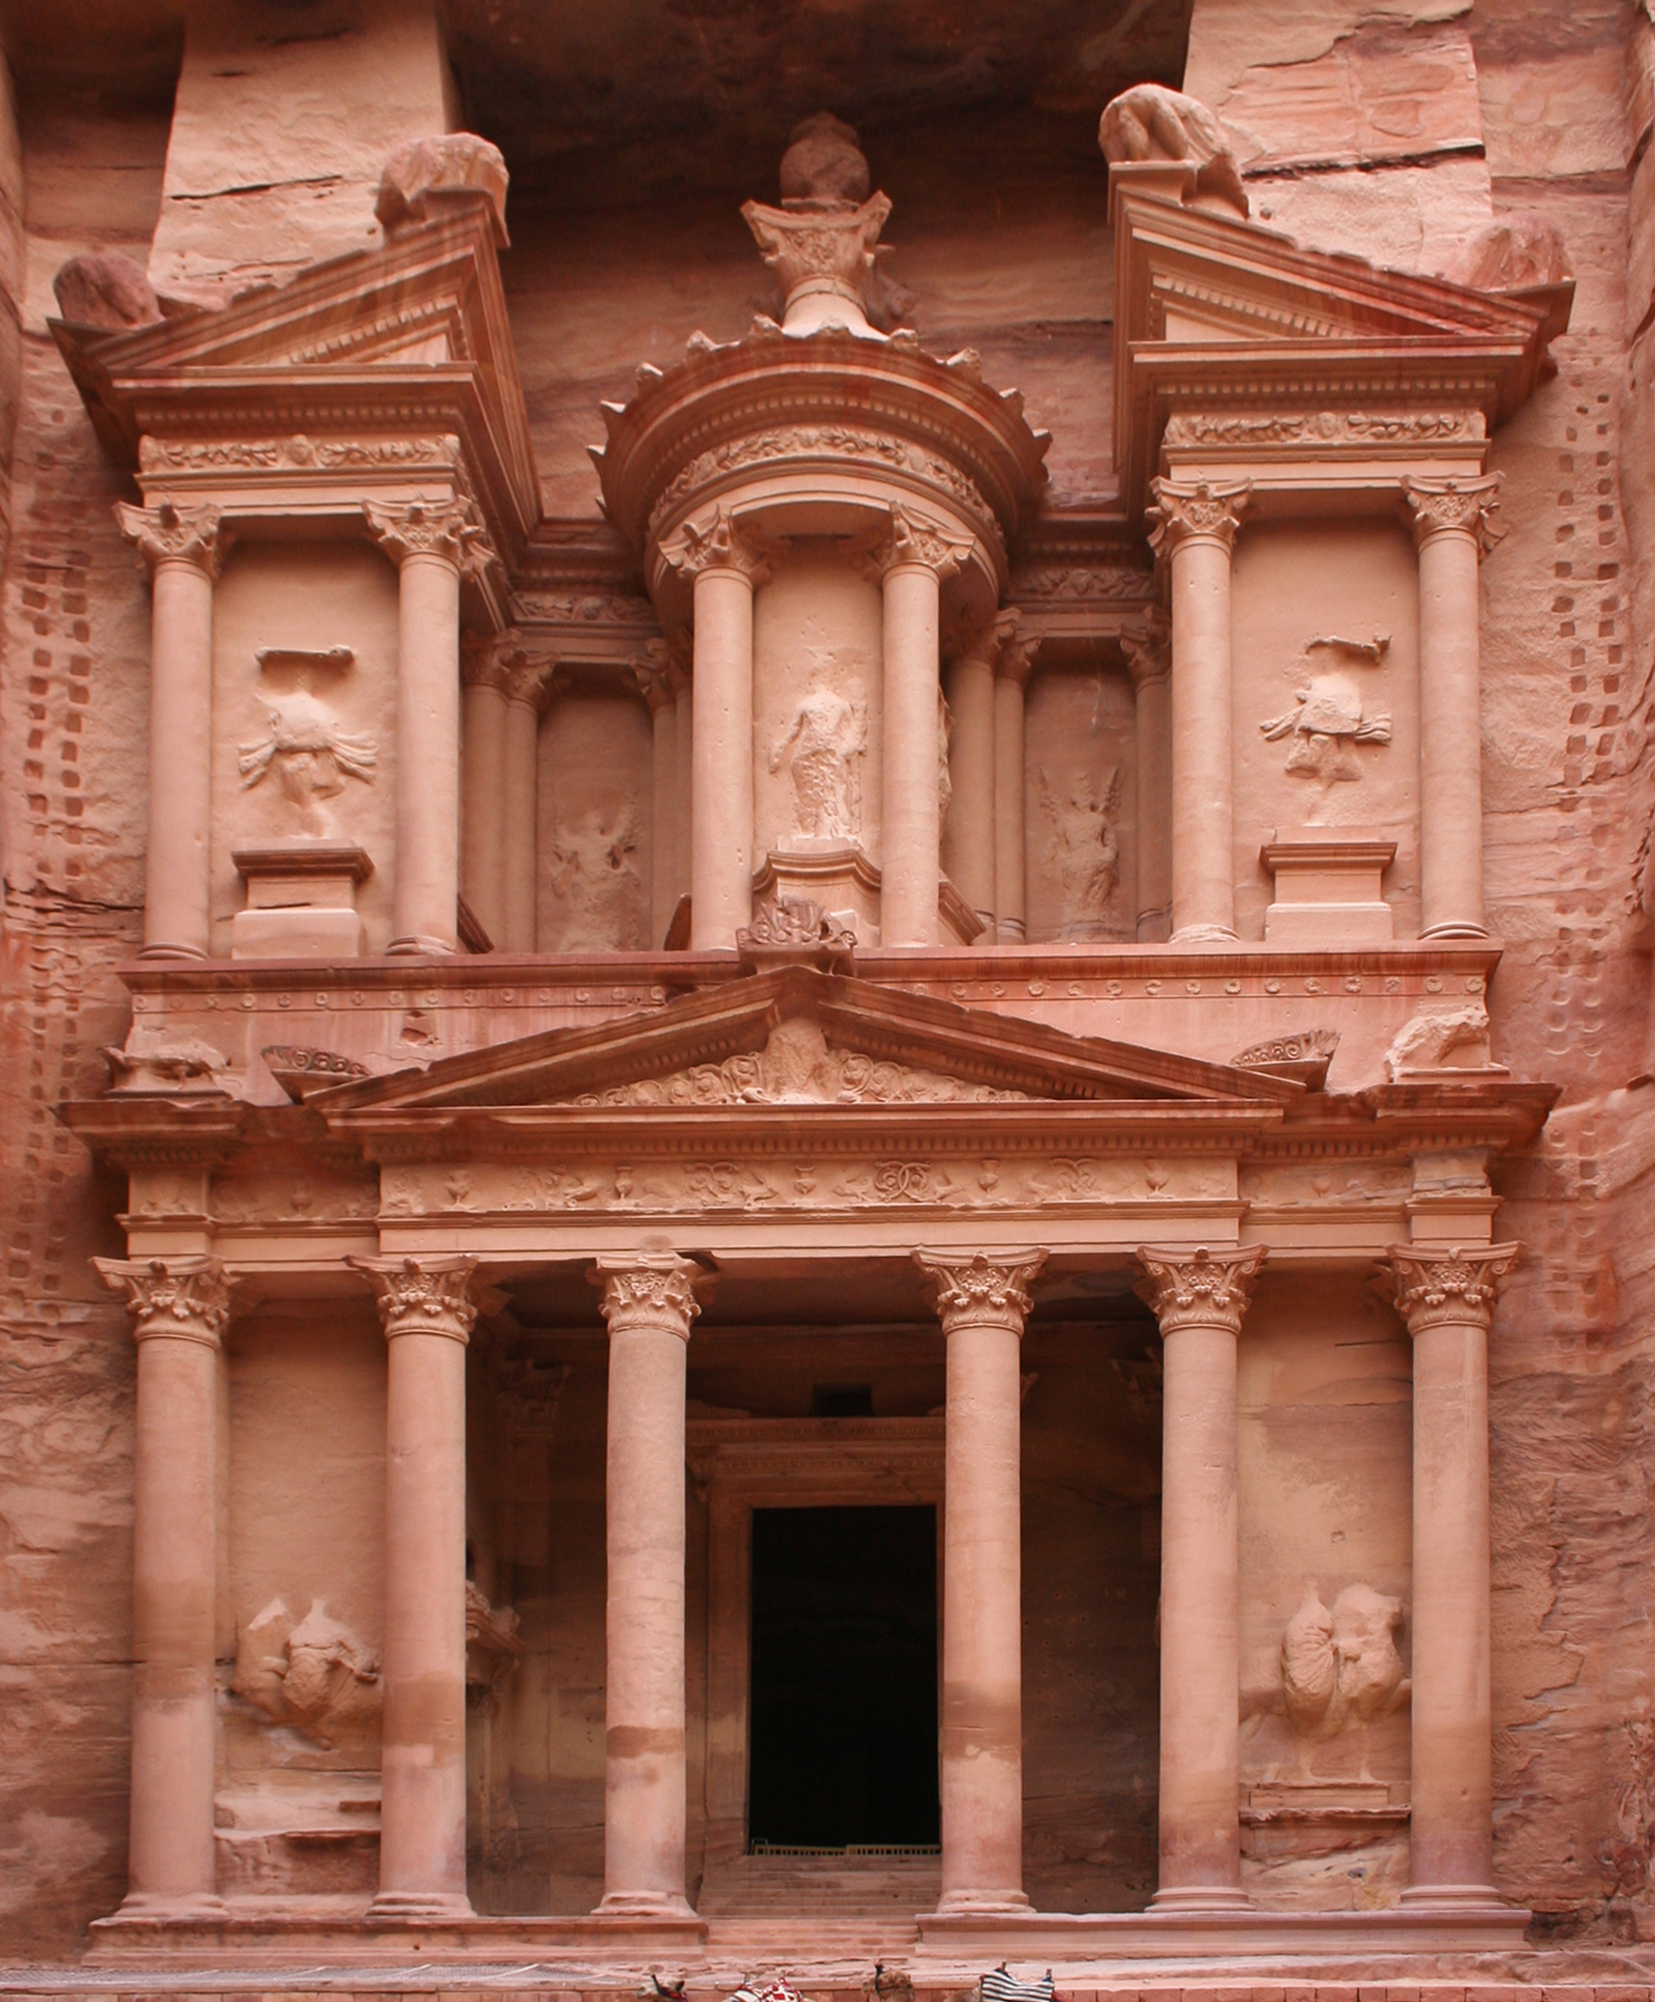Write a detailed description of the given image. The image presents a detailed view of Al-Khazneh, also known as The Treasury, located in the ancient city of Petra, Jordan. This architectural masterpiece, carved directly into pink sandstone cliffs, stands as a prime example of the Nabataean civilization's ingenuity. The front of the temple features a classical Greek-influenced façade with intricately detailed Corinthian columns, a broken pediment, and a central tholos topped with a timeless urn. Statues and relief carvings, although weathered by time, still showcase the facade's artistic achievements. This iconic monument, believed to be constructed in the 1st century BC, serves not only as a tomb but also as a storeroom and a place of reverence, mysteriously alluring visitors from around the world with its history and dramatic reveal through a narrow canyon. 